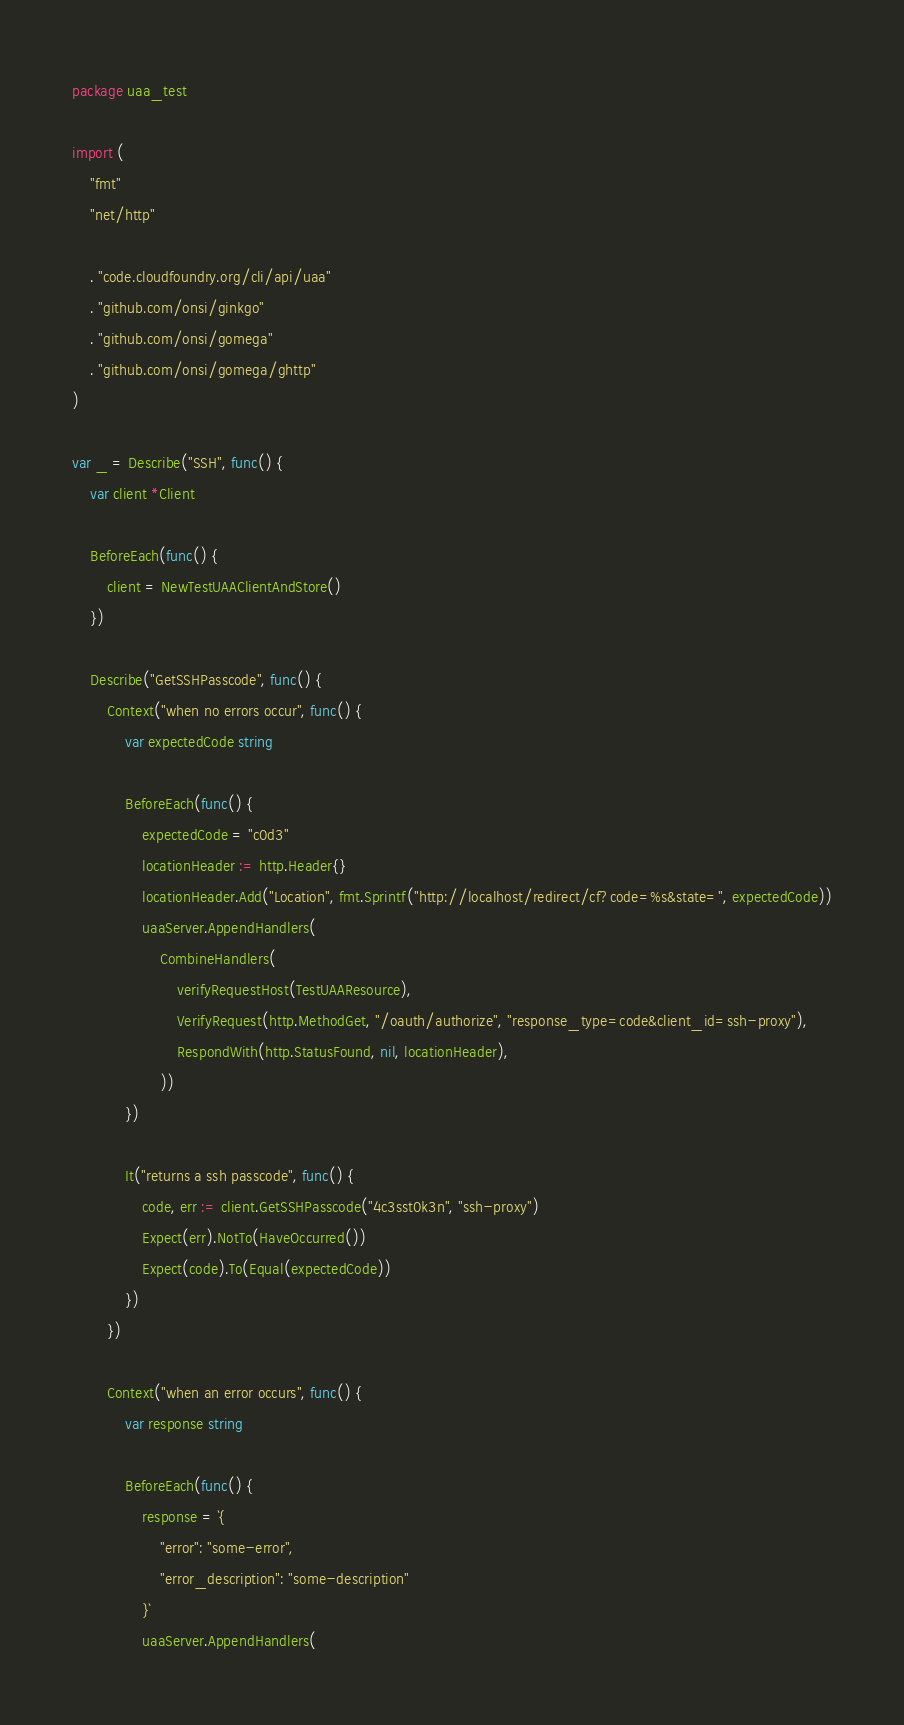Convert code to text. <code><loc_0><loc_0><loc_500><loc_500><_Go_>package uaa_test

import (
	"fmt"
	"net/http"

	. "code.cloudfoundry.org/cli/api/uaa"
	. "github.com/onsi/ginkgo"
	. "github.com/onsi/gomega"
	. "github.com/onsi/gomega/ghttp"
)

var _ = Describe("SSH", func() {
	var client *Client

	BeforeEach(func() {
		client = NewTestUAAClientAndStore()
	})

	Describe("GetSSHPasscode", func() {
		Context("when no errors occur", func() {
			var expectedCode string

			BeforeEach(func() {
				expectedCode = "c0d3"
				locationHeader := http.Header{}
				locationHeader.Add("Location", fmt.Sprintf("http://localhost/redirect/cf?code=%s&state=", expectedCode))
				uaaServer.AppendHandlers(
					CombineHandlers(
						verifyRequestHost(TestUAAResource),
						VerifyRequest(http.MethodGet, "/oauth/authorize", "response_type=code&client_id=ssh-proxy"),
						RespondWith(http.StatusFound, nil, locationHeader),
					))
			})

			It("returns a ssh passcode", func() {
				code, err := client.GetSSHPasscode("4c3sst0k3n", "ssh-proxy")
				Expect(err).NotTo(HaveOccurred())
				Expect(code).To(Equal(expectedCode))
			})
		})

		Context("when an error occurs", func() {
			var response string

			BeforeEach(func() {
				response = `{
					"error": "some-error",
					"error_description": "some-description"
				}`
				uaaServer.AppendHandlers(</code> 